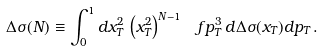Convert formula to latex. <formula><loc_0><loc_0><loc_500><loc_500>\Delta \sigma ( N ) \equiv \int _ { 0 } ^ { 1 } d x _ { T } ^ { 2 } \, \left ( x _ { T } ^ { 2 } \right ) ^ { N - 1 } \, \ f { p _ { T } ^ { 3 } \, d \Delta \sigma ( x _ { T } ) } { d p _ { T } } \, .</formula> 